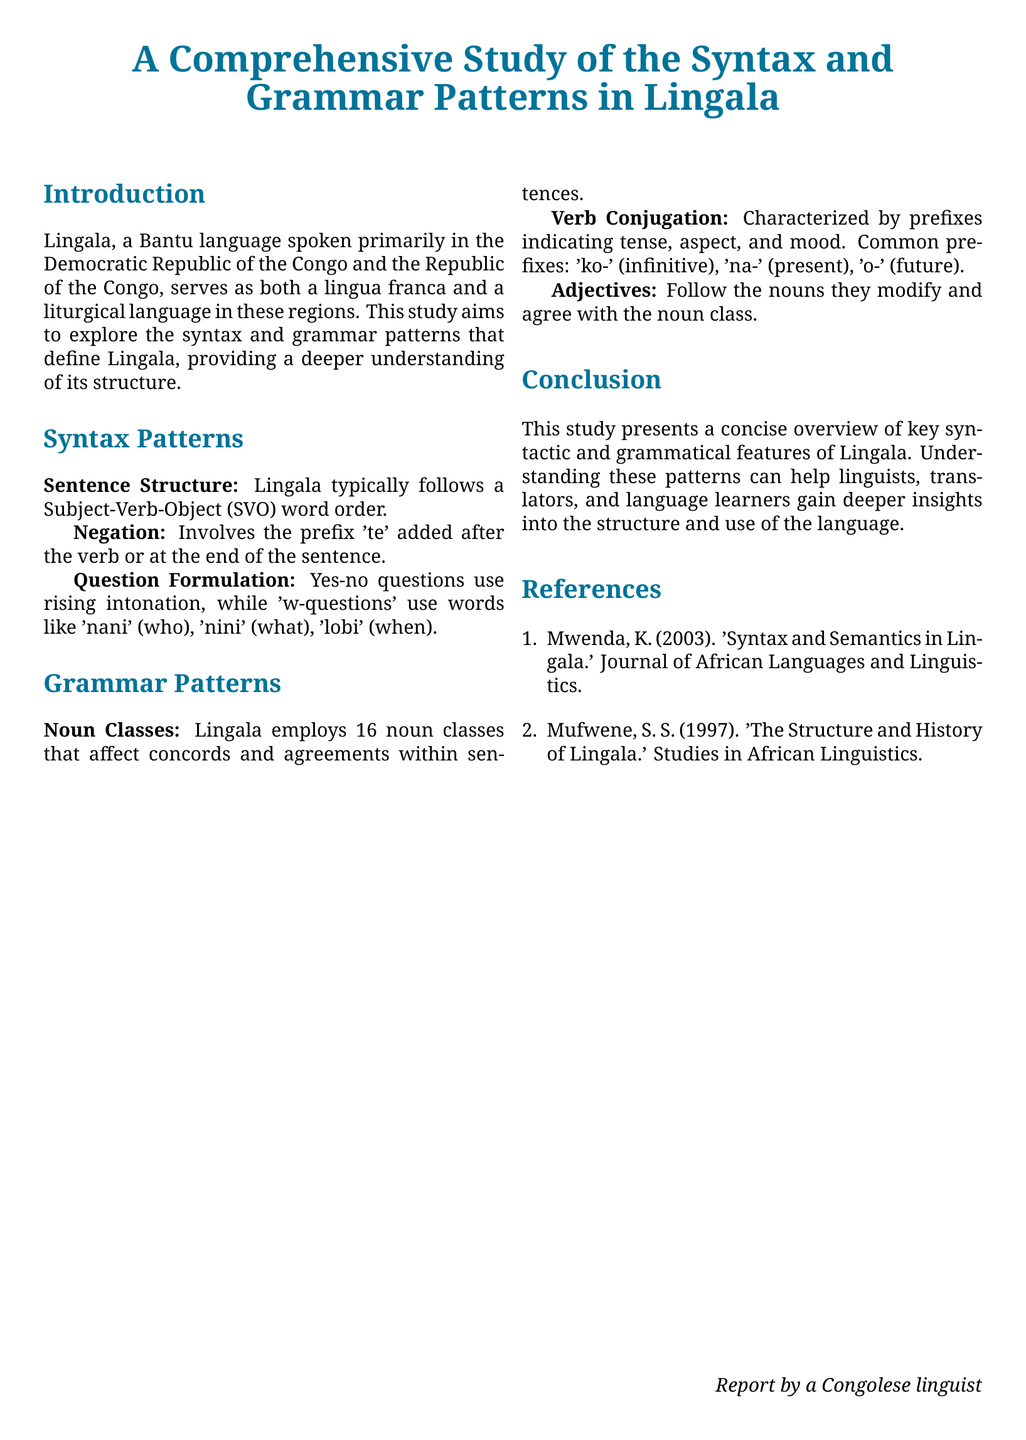What language is primarily studied in the document? The document focuses on the syntax and grammar patterns of a specific language, which is explicitly mentioned in the title.
Answer: Lingala What is the typical sentence structure in Lingala? The document explicitly states the typical word order followed in Lingala sentences.
Answer: Subject-Verb-Object What prefix is used for negation in Lingala? Negation in Lingala is discussed in a specific section, which mentions the prefix used.
Answer: te How many noun classes does Lingala employ? The number of noun classes is clearly stated in the section discussing grammar patterns.
Answer: 16 What is the infinitive prefix in Lingala verb conjugation? The section on verb conjugation provides specific prefixes used to indicate various tenses.
Answer: ko- Which word corresponds to "who" in Lingala questions? The document lists several interrogative words used in Lingala, including the word for "who."
Answer: nani What is the purpose of the study outlined in the document? The introduction states the aim of the study regarding the language being examined.
Answer: Explore syntax and grammar patterns Who is the author of the first reference listed? The document provides author names for references at the end, specifically for the first entry.
Answer: Mwenda What section provides information on adjectives in Lingala? The grammatical feature concerning adjectives is specified within a certain section of the document.
Answer: Grammar Patterns 